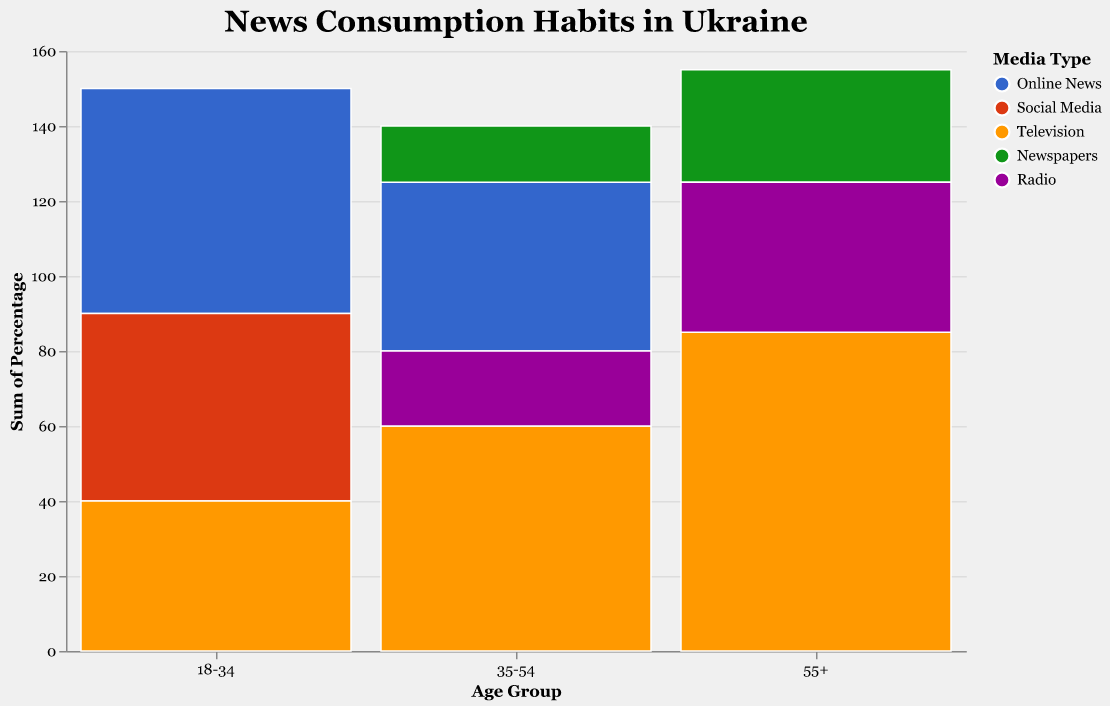What is the most popular media type among the age group 18-34 in urban areas? The figure shows that for the age group 18-34 in urban areas, the largest segment is Online News, with the highest percentage.
Answer: Online News What percentage of the rural population aged 55+ consumes newspapers? By looking at the rural location for the 55+ age group, newspapers are shown with a percentage of 10.
Answer: 10% Which age group in urban areas has the highest percentage of television consumption? Among the urban age groups, the 55+ age group has the highest percentage for television consumption, depicted by a bar reaching 40%.
Answer: 55+ How does the consumption of online news differ between urban and rural areas for the age group 35-54? In urban areas, the percentage for online news in the 35-54 age group is 30%, whereas in rural areas, it is 15%. The difference is 30% - 15% = 15%.
Answer: 15% Compare the consumption percentages of social media and online news within rural areas for the age group 18-34. For the age group 18-34 in rural areas, social media consumption is at 20% and online news is at 25%. Online news is higher by 25% - 20% = 5%.
Answer: 5% Which location (urban or rural) and age group (18-34, 35-54, 55+) collectively consume the most radio? Observing all the radio consumption percentages, the highest percentage is seen in the rural 55+ age group with 25%.
Answer: Rural 55+ What is the total percentage of newspaper consumption among the 55+ age group in both urban and rural areas? Add the newspaper percentages for the 55+ age group in urban (20%) and rural (10%) areas: 20% + 10% = 30%.
Answer: 30% Which media type has the lowest consumption in urban areas for the age group 35-54? Within the urban 35-54 age group, newspapers have the lowest consumption with a percentage of 15, as indicated by the smallest bar.
Answer: Newspapers What is the difference in percentage of television consumption between urban and rural areas among the 35-54 age group? Look at the television consumption percentages for the age group 35-54: Urban is 25%, Rural is 35%. The difference is 35% - 25% = 10%.
Answer: 10% Identify the most consumed media type for rural areas across all age groups. The figure shows that for rural areas, television has the highest percentages across all age groups: 25% for 18-34, 35% for 35-54, 45% for 55+.
Answer: Television 